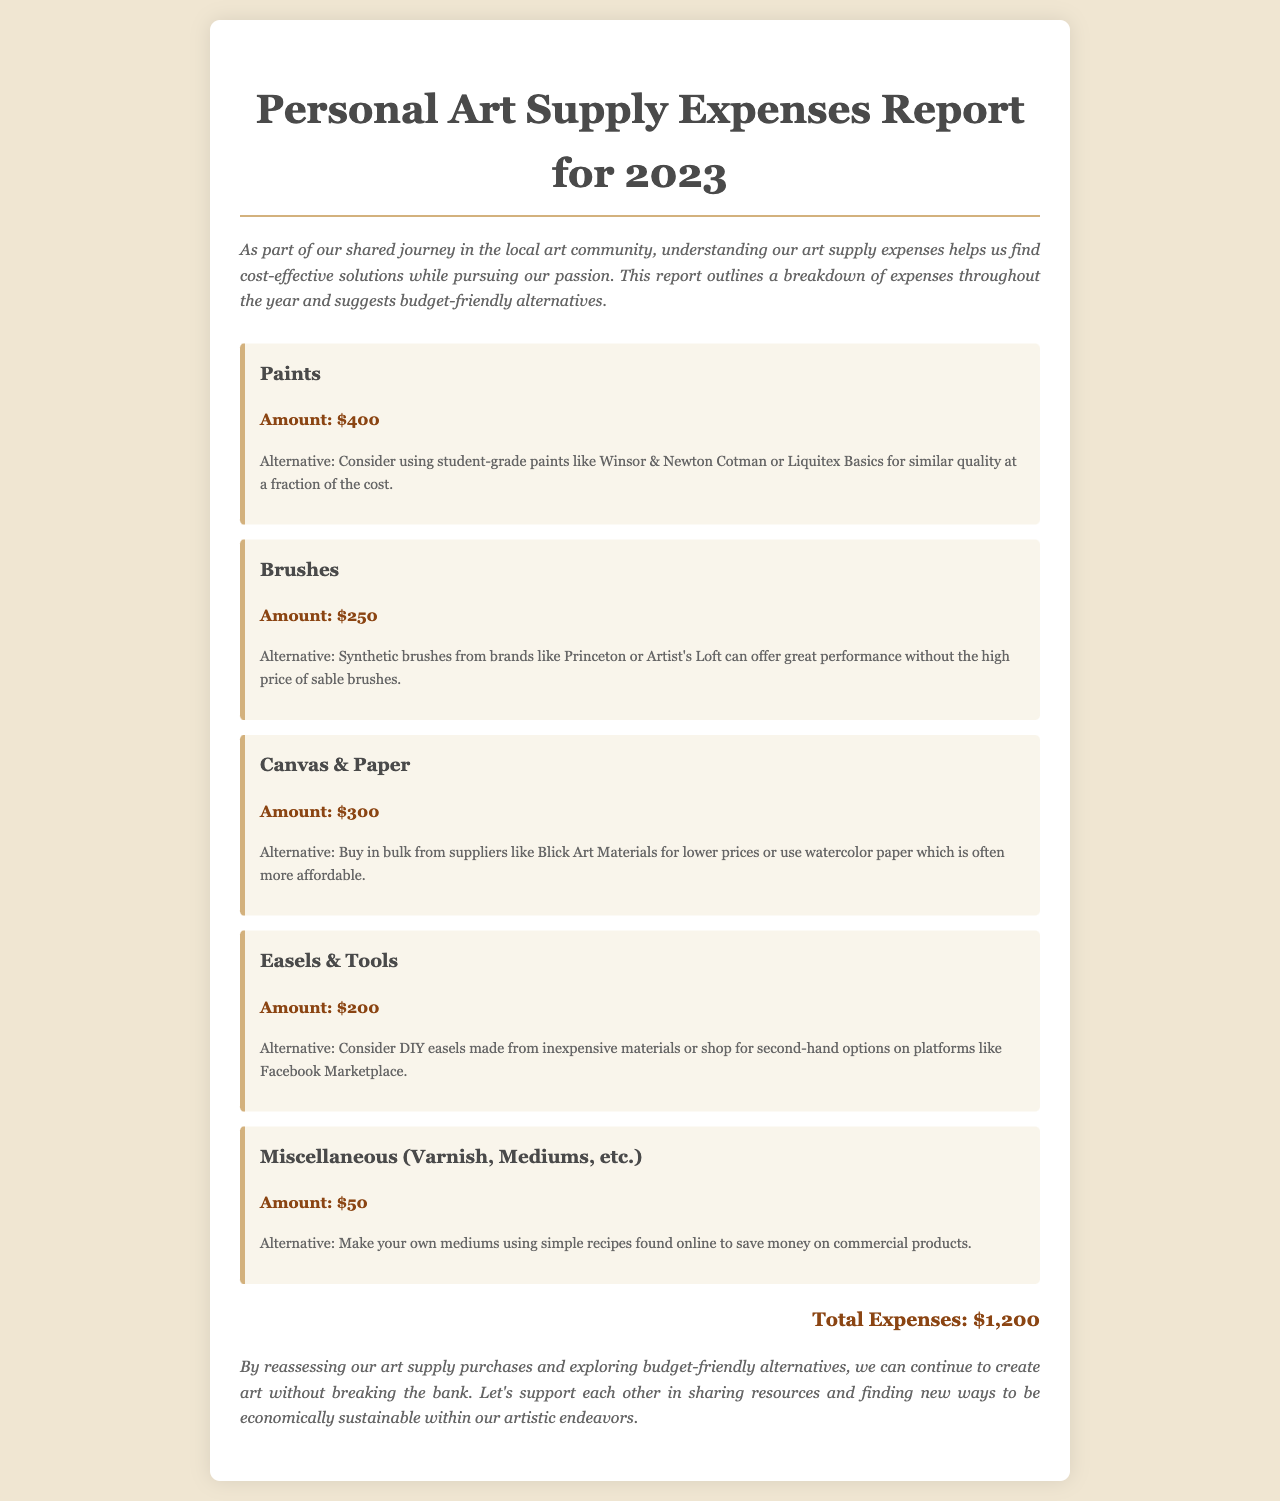What is the total amount spent on Paints? The total amount spent on Paints is explicitly stated in the document as $400.
Answer: $400 How much was spent on Brushes? The amount spent on Brushes is detailed in the report, amounting to $250.
Answer: $250 What is the suggested alternative for Canvas & Paper? The document recommends buying in bulk from suppliers like Blick Art Materials or using watercolor paper as an alternative for Canvas & Paper.
Answer: Buy in bulk from Blick Art Materials or use watercolor paper What is the total expenses listed in the report? The total expenses are summed up at the end of the document, totaling $1,200.
Answer: $1,200 What category has the lowest spending? The category with the lowest spending, according to the expense breakdown in the report, is Miscellaneous with an expense of $50.
Answer: Miscellaneous What is one budget-friendly suggestion for Easels & Tools? The report suggests considering DIY easels made from inexpensive materials or shopping for second-hand options.
Answer: DIY easels or second-hand options How many categories are listed for art supplies? There are five categories listed for art supplies in the document.
Answer: Five What is the purpose of the report? The report aims to help understand art supply expenses and find cost-effective solutions in the local art community.
Answer: Understand expenses and find cost-effective solutions 